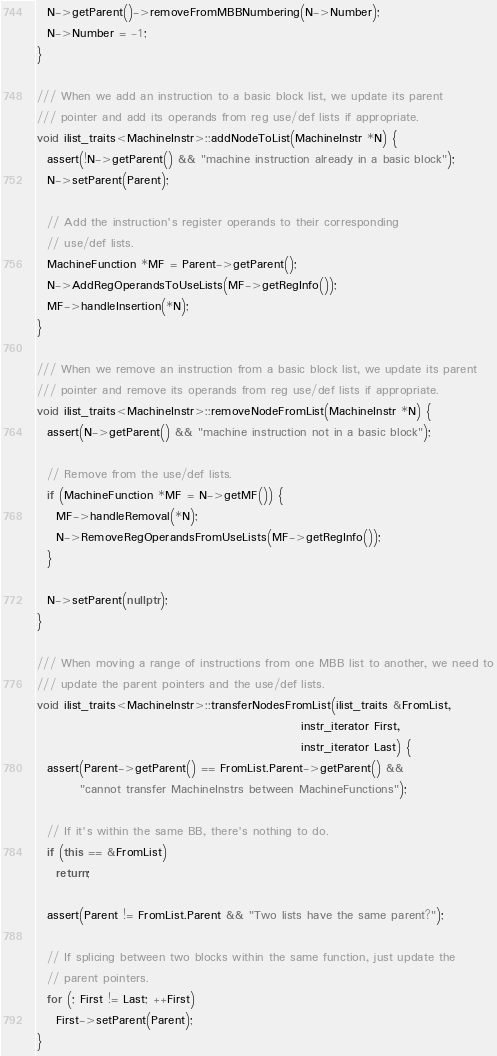<code> <loc_0><loc_0><loc_500><loc_500><_C++_>  N->getParent()->removeFromMBBNumbering(N->Number);
  N->Number = -1;
}

/// When we add an instruction to a basic block list, we update its parent
/// pointer and add its operands from reg use/def lists if appropriate.
void ilist_traits<MachineInstr>::addNodeToList(MachineInstr *N) {
  assert(!N->getParent() && "machine instruction already in a basic block");
  N->setParent(Parent);

  // Add the instruction's register operands to their corresponding
  // use/def lists.
  MachineFunction *MF = Parent->getParent();
  N->AddRegOperandsToUseLists(MF->getRegInfo());
  MF->handleInsertion(*N);
}

/// When we remove an instruction from a basic block list, we update its parent
/// pointer and remove its operands from reg use/def lists if appropriate.
void ilist_traits<MachineInstr>::removeNodeFromList(MachineInstr *N) {
  assert(N->getParent() && "machine instruction not in a basic block");

  // Remove from the use/def lists.
  if (MachineFunction *MF = N->getMF()) {
    MF->handleRemoval(*N);
    N->RemoveRegOperandsFromUseLists(MF->getRegInfo());
  }

  N->setParent(nullptr);
}

/// When moving a range of instructions from one MBB list to another, we need to
/// update the parent pointers and the use/def lists.
void ilist_traits<MachineInstr>::transferNodesFromList(ilist_traits &FromList,
                                                       instr_iterator First,
                                                       instr_iterator Last) {
  assert(Parent->getParent() == FromList.Parent->getParent() &&
         "cannot transfer MachineInstrs between MachineFunctions");

  // If it's within the same BB, there's nothing to do.
  if (this == &FromList)
    return;

  assert(Parent != FromList.Parent && "Two lists have the same parent?");

  // If splicing between two blocks within the same function, just update the
  // parent pointers.
  for (; First != Last; ++First)
    First->setParent(Parent);
}
</code> 